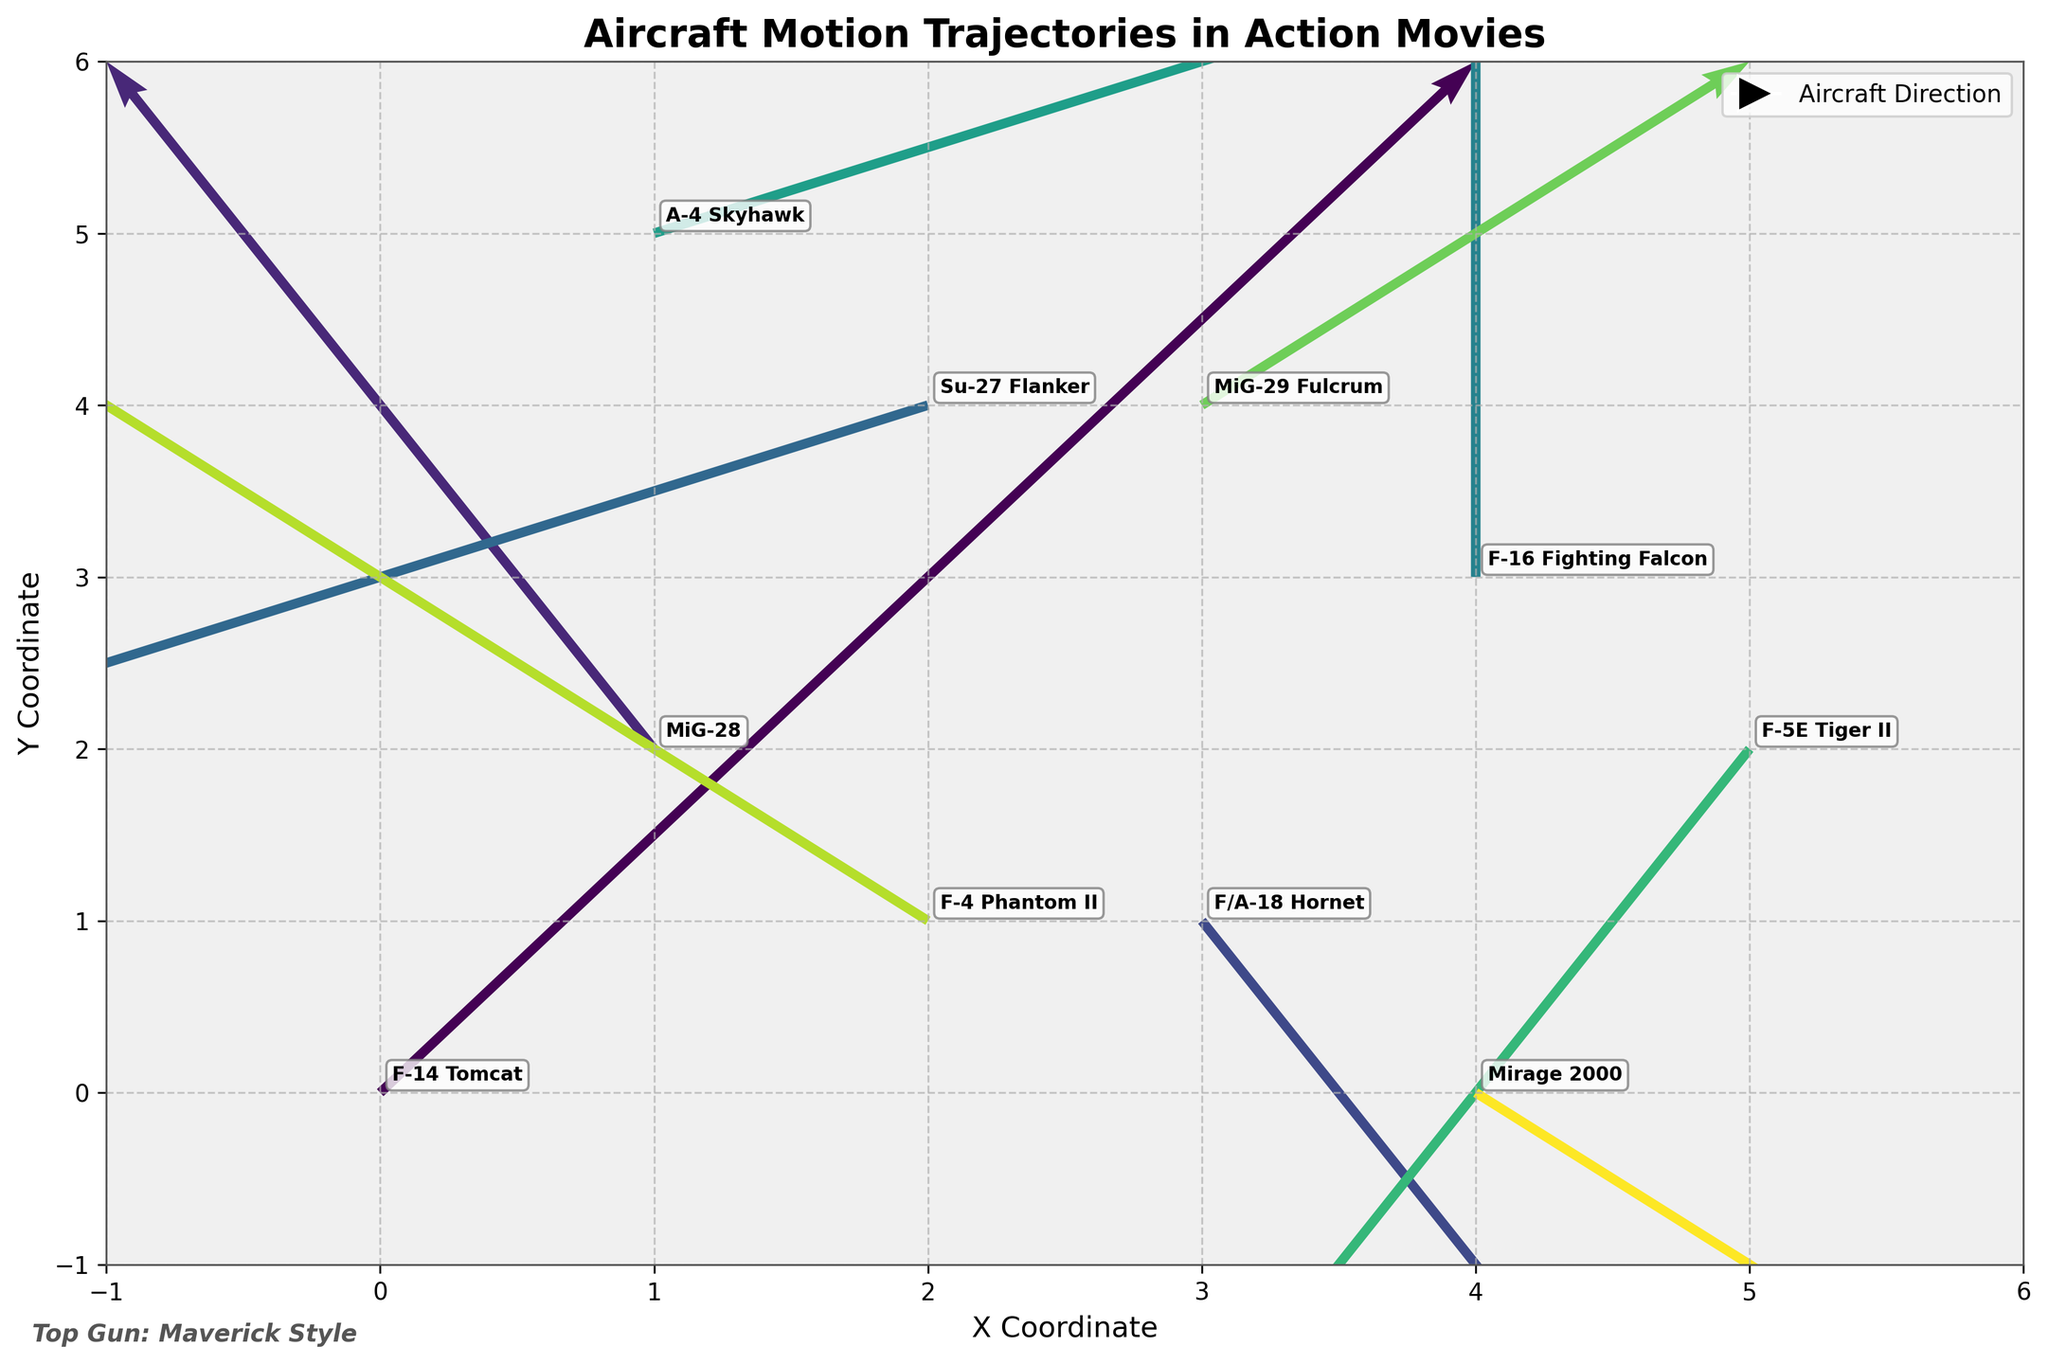What is the title of the figure? The title of the figure is written in a larger font at the top of the plot and it reads "Aircraft Motion Trajectories in Action Movies".
Answer: Aircraft Motion Trajectories in Action Movies How many aircraft are represented in the figure? The plot annotates each aircraft with a label at their respective starting positions. By counting these labels, we can determine the number of aircraft.
Answer: 10 Which aircraft starts at the coordinate (0, 0)? The figure marks the starting positions of each aircraft with labels. The aircraft that starts at (0, 0) is labeled as "F-14 Tomcat".
Answer: F-14 Tomcat Which aircraft has the largest vertical displacement? The length of the vertical vector component (v) must be maximum. By comparing the arrow lengths visually or using the 'v' values, the "F-14 Tomcat" with v = 3 has the largest vertical displacement.
Answer: F-14 Tomcat How many aircraft exhibit a downward trajectory? Aircraft with downward trajectories have negative v components. By counting the arrows pointing downward, we identify the MiG-29 Fulcrum, F/A-18 Hornet, Mirage 2000, Su-27 Flanker, and F-5E Tiger II.
Answer: 5 Which aircraft starts at (4, 0) and in which direction is it moving? By locating the label at (4, 0), we find the "Mirage 2000". The direction is given by the vector components; based on the arrow, it is moving slightly right and downward.
Answer: Mirage 2000, slightly right and downward Which two aircraft move to the right with a vector of 2 units length horizontally? Aircraft moving 2 units to the right have 'u' = 2. Checking the data labels, the F-14 Tomcat and A-4 Skyhawk move right with u = 2.
Answer: F-14 Tomcat and A-4 Skyhawk Compare the vertical displacements of the F-4 Phantom II and the F-5E Tiger II. Which one has a greater vertical component? The F-4 Phantom II has a vertical component v = 2, while the F-5E Tiger II has v = -2. Since 2 > -2, the F-4 Phantom II has a greater vertical component.
Answer: F-4 Phantom II What are the x and y coordinate bounds of the quiver plot? The xy-limits of the plot are visible along the axes. The x-axis ranges from -1 to 6, and the y-axis ranges from -1 to 6 corresponding to the aircraft trajectories depicted.
Answer: -1 to 6 How many aircraft have horizontal displacements to the left? Aircraft moving to the left have negative horizontal components (u). By counting the arrows moving leftward within the plot, we identify the MiG-28, F-5E Tiger II, Su-27 Flanker, and F-4 Phantom II.
Answer: 4 